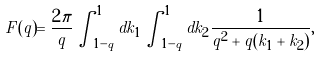<formula> <loc_0><loc_0><loc_500><loc_500>F ( q ) = \frac { 2 \pi } { q } \int _ { 1 - q } ^ { 1 } d k _ { 1 } \int _ { 1 - q } ^ { 1 } d k _ { 2 } \frac { 1 } { q ^ { 2 } + q ( k _ { 1 } + k _ { 2 } ) } ,</formula> 